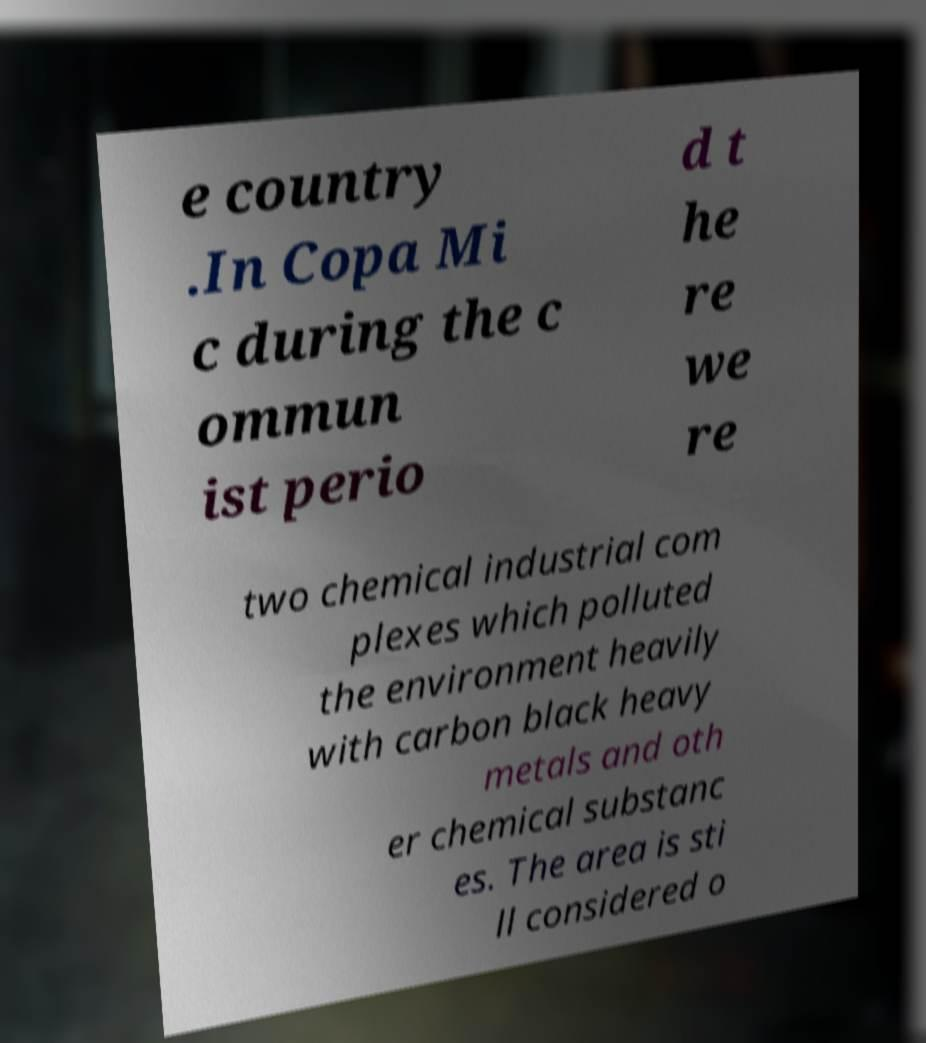Can you accurately transcribe the text from the provided image for me? e country .In Copa Mi c during the c ommun ist perio d t he re we re two chemical industrial com plexes which polluted the environment heavily with carbon black heavy metals and oth er chemical substanc es. The area is sti ll considered o 